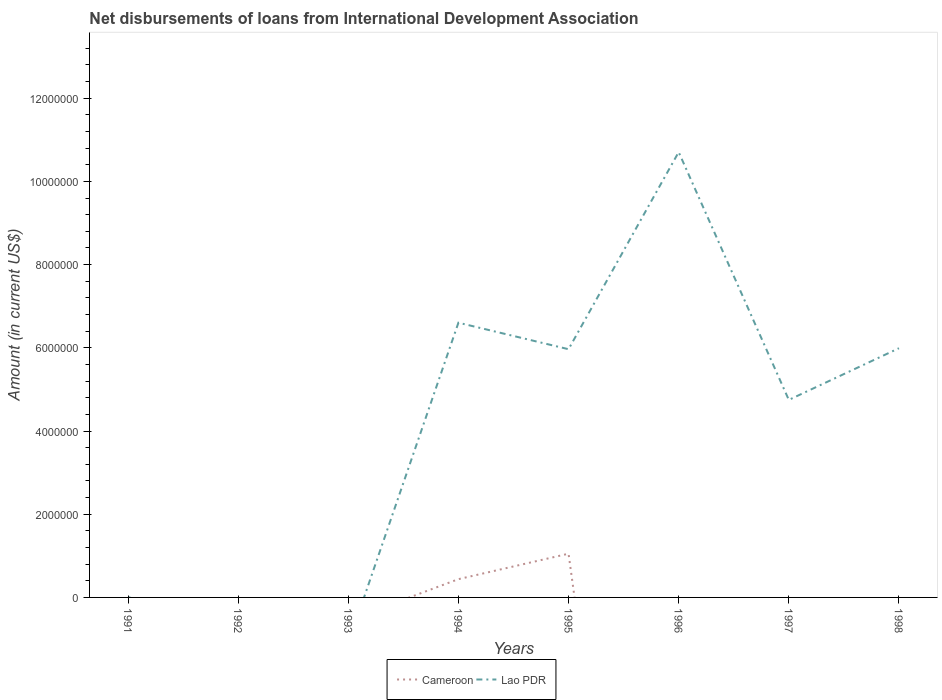Does the line corresponding to Cameroon intersect with the line corresponding to Lao PDR?
Provide a succinct answer. Yes. What is the total amount of loans disbursed in Cameroon in the graph?
Offer a very short reply. -6.12e+05. What is the difference between the highest and the second highest amount of loans disbursed in Lao PDR?
Offer a terse response. 1.07e+07. Is the amount of loans disbursed in Lao PDR strictly greater than the amount of loans disbursed in Cameroon over the years?
Your answer should be compact. No. Are the values on the major ticks of Y-axis written in scientific E-notation?
Make the answer very short. No. How many legend labels are there?
Offer a very short reply. 2. How are the legend labels stacked?
Provide a short and direct response. Horizontal. What is the title of the graph?
Offer a very short reply. Net disbursements of loans from International Development Association. Does "Botswana" appear as one of the legend labels in the graph?
Offer a very short reply. No. What is the Amount (in current US$) in Lao PDR in 1991?
Provide a short and direct response. 1.10e+04. What is the Amount (in current US$) of Cameroon in 1992?
Provide a succinct answer. 0. What is the Amount (in current US$) in Lao PDR in 1993?
Offer a very short reply. 0. What is the Amount (in current US$) of Cameroon in 1994?
Your response must be concise. 4.39e+05. What is the Amount (in current US$) in Lao PDR in 1994?
Your response must be concise. 6.60e+06. What is the Amount (in current US$) in Cameroon in 1995?
Give a very brief answer. 1.05e+06. What is the Amount (in current US$) of Lao PDR in 1995?
Ensure brevity in your answer.  5.97e+06. What is the Amount (in current US$) in Lao PDR in 1996?
Give a very brief answer. 1.07e+07. What is the Amount (in current US$) in Cameroon in 1997?
Make the answer very short. 0. What is the Amount (in current US$) in Lao PDR in 1997?
Offer a terse response. 4.75e+06. What is the Amount (in current US$) of Cameroon in 1998?
Your answer should be compact. 0. What is the Amount (in current US$) in Lao PDR in 1998?
Keep it short and to the point. 5.99e+06. Across all years, what is the maximum Amount (in current US$) in Cameroon?
Provide a succinct answer. 1.05e+06. Across all years, what is the maximum Amount (in current US$) in Lao PDR?
Offer a very short reply. 1.07e+07. Across all years, what is the minimum Amount (in current US$) in Cameroon?
Provide a succinct answer. 0. What is the total Amount (in current US$) in Cameroon in the graph?
Make the answer very short. 1.49e+06. What is the total Amount (in current US$) of Lao PDR in the graph?
Keep it short and to the point. 3.40e+07. What is the difference between the Amount (in current US$) in Lao PDR in 1991 and that in 1994?
Give a very brief answer. -6.59e+06. What is the difference between the Amount (in current US$) of Lao PDR in 1991 and that in 1995?
Your answer should be very brief. -5.96e+06. What is the difference between the Amount (in current US$) of Lao PDR in 1991 and that in 1996?
Provide a succinct answer. -1.07e+07. What is the difference between the Amount (in current US$) in Lao PDR in 1991 and that in 1997?
Your answer should be very brief. -4.74e+06. What is the difference between the Amount (in current US$) in Lao PDR in 1991 and that in 1998?
Offer a very short reply. -5.98e+06. What is the difference between the Amount (in current US$) in Cameroon in 1994 and that in 1995?
Your response must be concise. -6.12e+05. What is the difference between the Amount (in current US$) in Lao PDR in 1994 and that in 1995?
Give a very brief answer. 6.37e+05. What is the difference between the Amount (in current US$) of Lao PDR in 1994 and that in 1996?
Your answer should be very brief. -4.10e+06. What is the difference between the Amount (in current US$) of Lao PDR in 1994 and that in 1997?
Give a very brief answer. 1.86e+06. What is the difference between the Amount (in current US$) in Lao PDR in 1994 and that in 1998?
Provide a short and direct response. 6.13e+05. What is the difference between the Amount (in current US$) of Lao PDR in 1995 and that in 1996?
Offer a terse response. -4.74e+06. What is the difference between the Amount (in current US$) in Lao PDR in 1995 and that in 1997?
Your answer should be compact. 1.22e+06. What is the difference between the Amount (in current US$) in Lao PDR in 1995 and that in 1998?
Provide a succinct answer. -2.40e+04. What is the difference between the Amount (in current US$) of Lao PDR in 1996 and that in 1997?
Keep it short and to the point. 5.96e+06. What is the difference between the Amount (in current US$) of Lao PDR in 1996 and that in 1998?
Offer a very short reply. 4.71e+06. What is the difference between the Amount (in current US$) of Lao PDR in 1997 and that in 1998?
Keep it short and to the point. -1.24e+06. What is the difference between the Amount (in current US$) in Cameroon in 1994 and the Amount (in current US$) in Lao PDR in 1995?
Offer a very short reply. -5.53e+06. What is the difference between the Amount (in current US$) of Cameroon in 1994 and the Amount (in current US$) of Lao PDR in 1996?
Ensure brevity in your answer.  -1.03e+07. What is the difference between the Amount (in current US$) in Cameroon in 1994 and the Amount (in current US$) in Lao PDR in 1997?
Your answer should be very brief. -4.31e+06. What is the difference between the Amount (in current US$) in Cameroon in 1994 and the Amount (in current US$) in Lao PDR in 1998?
Keep it short and to the point. -5.55e+06. What is the difference between the Amount (in current US$) of Cameroon in 1995 and the Amount (in current US$) of Lao PDR in 1996?
Ensure brevity in your answer.  -9.65e+06. What is the difference between the Amount (in current US$) of Cameroon in 1995 and the Amount (in current US$) of Lao PDR in 1997?
Offer a very short reply. -3.70e+06. What is the difference between the Amount (in current US$) in Cameroon in 1995 and the Amount (in current US$) in Lao PDR in 1998?
Give a very brief answer. -4.94e+06. What is the average Amount (in current US$) in Cameroon per year?
Offer a terse response. 1.86e+05. What is the average Amount (in current US$) in Lao PDR per year?
Your answer should be very brief. 4.25e+06. In the year 1994, what is the difference between the Amount (in current US$) in Cameroon and Amount (in current US$) in Lao PDR?
Provide a short and direct response. -6.16e+06. In the year 1995, what is the difference between the Amount (in current US$) of Cameroon and Amount (in current US$) of Lao PDR?
Make the answer very short. -4.92e+06. What is the ratio of the Amount (in current US$) in Lao PDR in 1991 to that in 1994?
Your answer should be compact. 0. What is the ratio of the Amount (in current US$) in Lao PDR in 1991 to that in 1995?
Offer a very short reply. 0. What is the ratio of the Amount (in current US$) of Lao PDR in 1991 to that in 1997?
Offer a very short reply. 0. What is the ratio of the Amount (in current US$) of Lao PDR in 1991 to that in 1998?
Your answer should be very brief. 0. What is the ratio of the Amount (in current US$) in Cameroon in 1994 to that in 1995?
Your answer should be compact. 0.42. What is the ratio of the Amount (in current US$) of Lao PDR in 1994 to that in 1995?
Ensure brevity in your answer.  1.11. What is the ratio of the Amount (in current US$) in Lao PDR in 1994 to that in 1996?
Give a very brief answer. 0.62. What is the ratio of the Amount (in current US$) in Lao PDR in 1994 to that in 1997?
Your response must be concise. 1.39. What is the ratio of the Amount (in current US$) in Lao PDR in 1994 to that in 1998?
Your answer should be very brief. 1.1. What is the ratio of the Amount (in current US$) in Lao PDR in 1995 to that in 1996?
Offer a terse response. 0.56. What is the ratio of the Amount (in current US$) of Lao PDR in 1995 to that in 1997?
Provide a short and direct response. 1.26. What is the ratio of the Amount (in current US$) of Lao PDR in 1995 to that in 1998?
Offer a very short reply. 1. What is the ratio of the Amount (in current US$) of Lao PDR in 1996 to that in 1997?
Ensure brevity in your answer.  2.25. What is the ratio of the Amount (in current US$) in Lao PDR in 1996 to that in 1998?
Your answer should be compact. 1.79. What is the ratio of the Amount (in current US$) of Lao PDR in 1997 to that in 1998?
Offer a terse response. 0.79. What is the difference between the highest and the second highest Amount (in current US$) in Lao PDR?
Provide a succinct answer. 4.10e+06. What is the difference between the highest and the lowest Amount (in current US$) of Cameroon?
Your answer should be compact. 1.05e+06. What is the difference between the highest and the lowest Amount (in current US$) of Lao PDR?
Keep it short and to the point. 1.07e+07. 